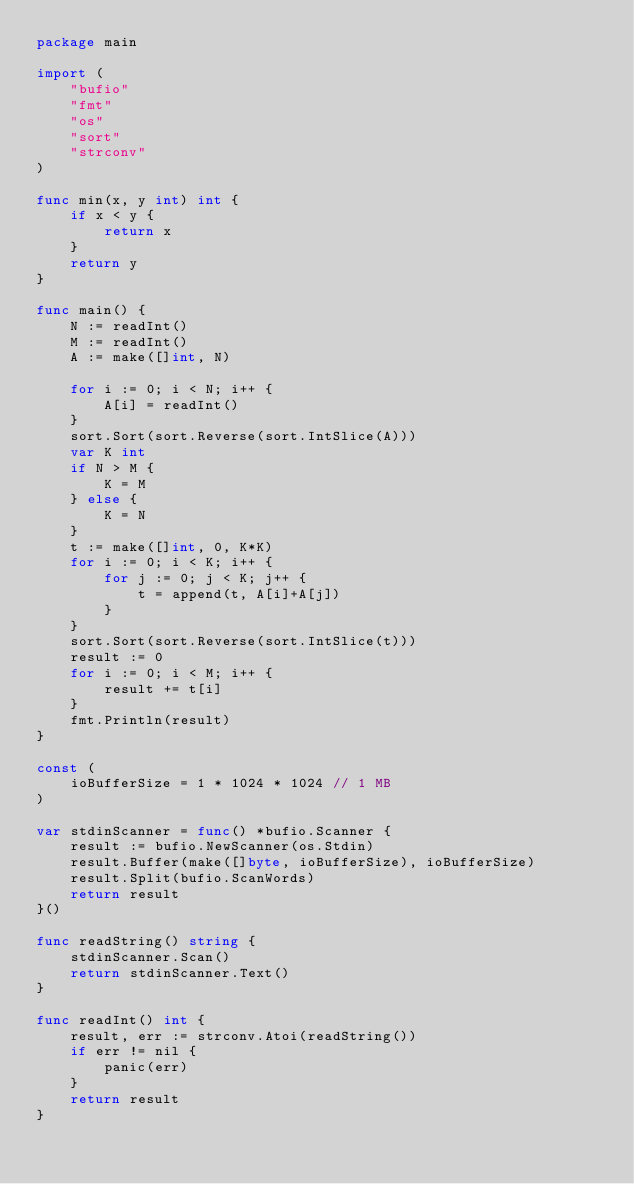<code> <loc_0><loc_0><loc_500><loc_500><_Go_>package main

import (
	"bufio"
	"fmt"
	"os"
	"sort"
	"strconv"
)

func min(x, y int) int {
	if x < y {
		return x
	}
	return y
}

func main() {
	N := readInt()
	M := readInt()
	A := make([]int, N)

	for i := 0; i < N; i++ {
		A[i] = readInt()
	}
	sort.Sort(sort.Reverse(sort.IntSlice(A)))
	var K int
	if N > M {
		K = M
	} else {
		K = N
	}
	t := make([]int, 0, K*K)
	for i := 0; i < K; i++ {
		for j := 0; j < K; j++ {
			t = append(t, A[i]+A[j])
		}
	}
	sort.Sort(sort.Reverse(sort.IntSlice(t)))
	result := 0
	for i := 0; i < M; i++ {
		result += t[i]
	}
	fmt.Println(result)
}

const (
	ioBufferSize = 1 * 1024 * 1024 // 1 MB
)

var stdinScanner = func() *bufio.Scanner {
	result := bufio.NewScanner(os.Stdin)
	result.Buffer(make([]byte, ioBufferSize), ioBufferSize)
	result.Split(bufio.ScanWords)
	return result
}()

func readString() string {
	stdinScanner.Scan()
	return stdinScanner.Text()
}

func readInt() int {
	result, err := strconv.Atoi(readString())
	if err != nil {
		panic(err)
	}
	return result
}
</code> 